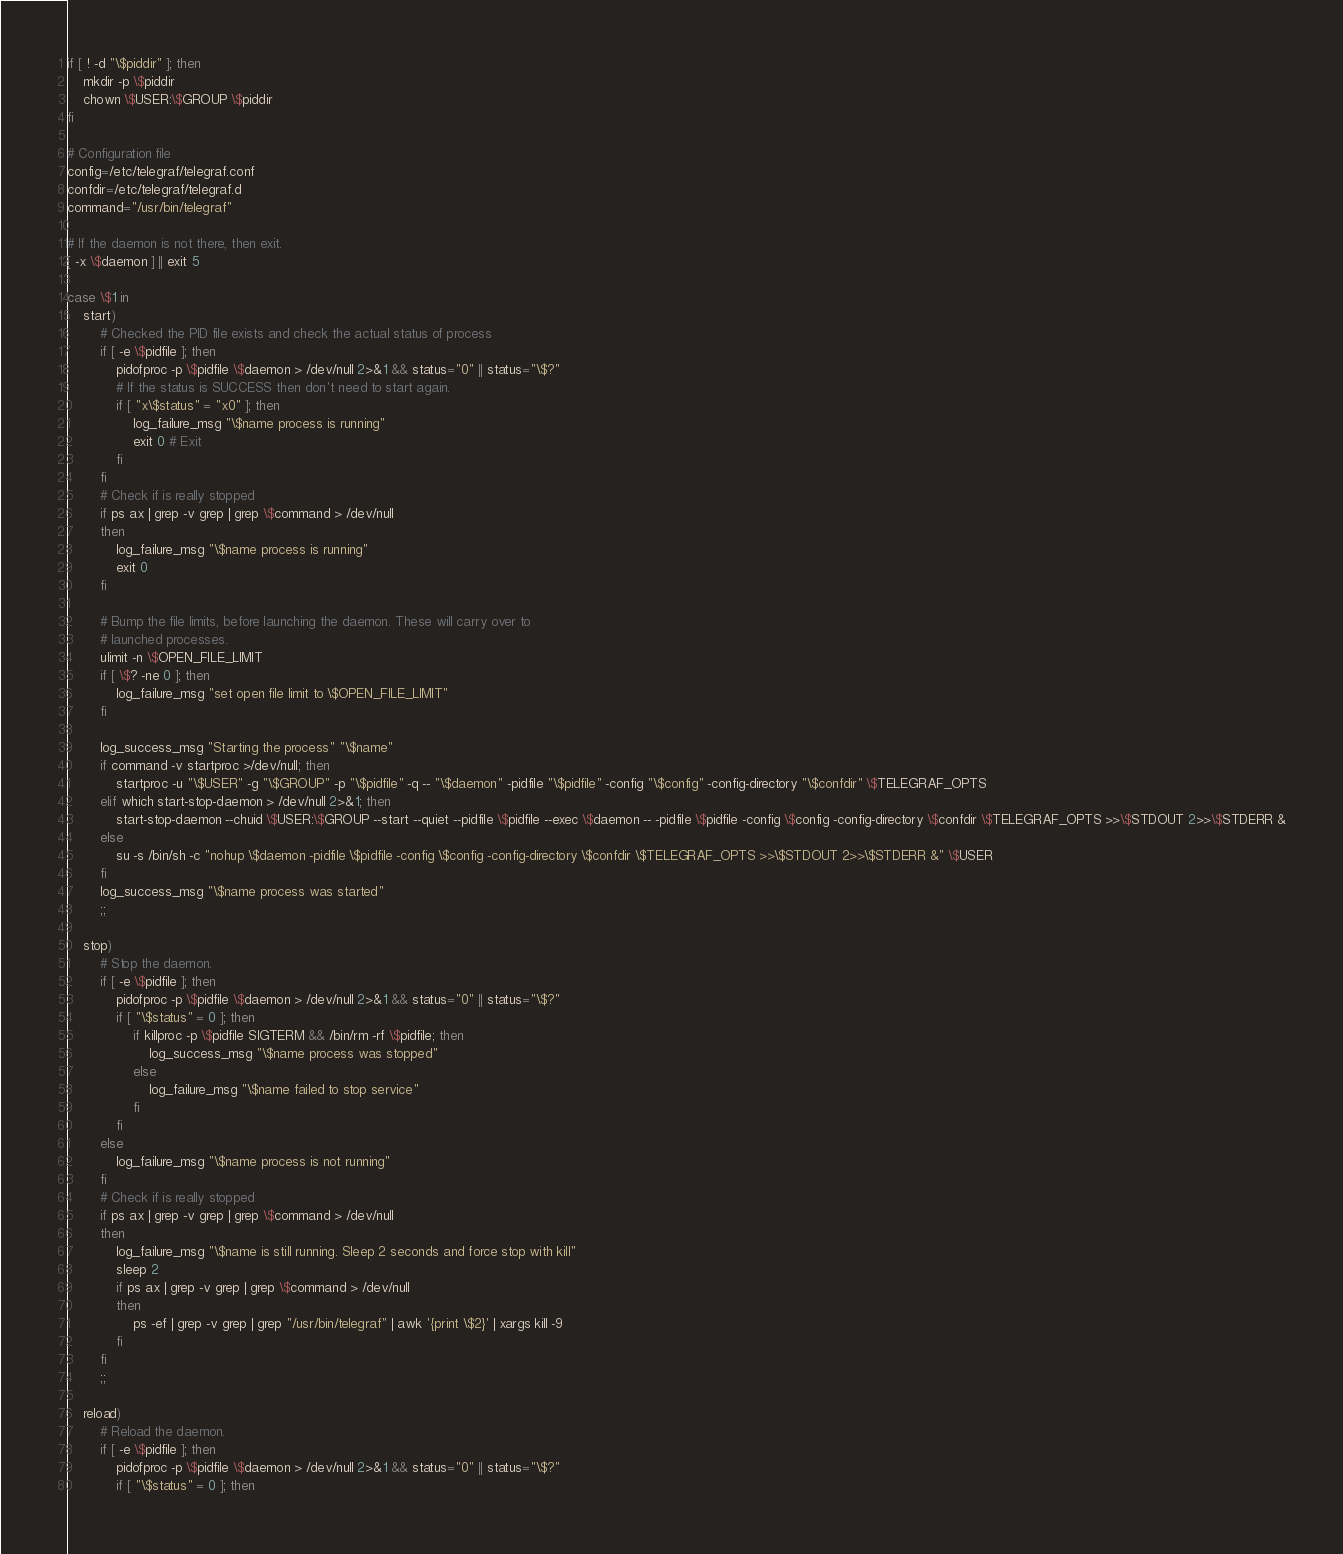<code> <loc_0><loc_0><loc_500><loc_500><_Bash_>if [ ! -d "\$piddir" ]; then
    mkdir -p \$piddir
    chown \$USER:\$GROUP \$piddir
fi

# Configuration file
config=/etc/telegraf/telegraf.conf
confdir=/etc/telegraf/telegraf.d
command="/usr/bin/telegraf"

# If the daemon is not there, then exit.
[ -x \$daemon ] || exit 5

case \$1 in
    start)
        # Checked the PID file exists and check the actual status of process
        if [ -e \$pidfile ]; then
            pidofproc -p \$pidfile \$daemon > /dev/null 2>&1 && status="0" || status="\$?"
            # If the status is SUCCESS then don't need to start again.
            if [ "x\$status" = "x0" ]; then
                log_failure_msg "\$name process is running"
                exit 0 # Exit
            fi
        fi
        # Check if is really stopped
        if ps ax | grep -v grep | grep \$command > /dev/null
        then
            log_failure_msg "\$name process is running"
            exit 0
        fi

        # Bump the file limits, before launching the daemon. These will carry over to
        # launched processes.
        ulimit -n \$OPEN_FILE_LIMIT
        if [ \$? -ne 0 ]; then
            log_failure_msg "set open file limit to \$OPEN_FILE_LIMIT"
        fi

        log_success_msg "Starting the process" "\$name"
        if command -v startproc >/dev/null; then
            startproc -u "\$USER" -g "\$GROUP" -p "\$pidfile" -q -- "\$daemon" -pidfile "\$pidfile" -config "\$config" -config-directory "\$confdir" \$TELEGRAF_OPTS
        elif which start-stop-daemon > /dev/null 2>&1; then
            start-stop-daemon --chuid \$USER:\$GROUP --start --quiet --pidfile \$pidfile --exec \$daemon -- -pidfile \$pidfile -config \$config -config-directory \$confdir \$TELEGRAF_OPTS >>\$STDOUT 2>>\$STDERR &
        else
            su -s /bin/sh -c "nohup \$daemon -pidfile \$pidfile -config \$config -config-directory \$confdir \$TELEGRAF_OPTS >>\$STDOUT 2>>\$STDERR &" \$USER
        fi
        log_success_msg "\$name process was started"
        ;;

    stop)
        # Stop the daemon.
        if [ -e \$pidfile ]; then
            pidofproc -p \$pidfile \$daemon > /dev/null 2>&1 && status="0" || status="\$?"
            if [ "\$status" = 0 ]; then
                if killproc -p \$pidfile SIGTERM && /bin/rm -rf \$pidfile; then
                    log_success_msg "\$name process was stopped"
                else
                    log_failure_msg "\$name failed to stop service"
                fi
            fi
        else
            log_failure_msg "\$name process is not running"
        fi
        # Check if is really stopped
        if ps ax | grep -v grep | grep \$command > /dev/null
        then
            log_failure_msg "\$name is still running. Sleep 2 seconds and force stop with kill"
            sleep 2
            if ps ax | grep -v grep | grep \$command > /dev/null
            then
                ps -ef | grep -v grep | grep "/usr/bin/telegraf" | awk '{print \$2}' | xargs kill -9
            fi
        fi
        ;;

    reload)
        # Reload the daemon.
        if [ -e \$pidfile ]; then
            pidofproc -p \$pidfile \$daemon > /dev/null 2>&1 && status="0" || status="\$?"
            if [ "\$status" = 0 ]; then</code> 